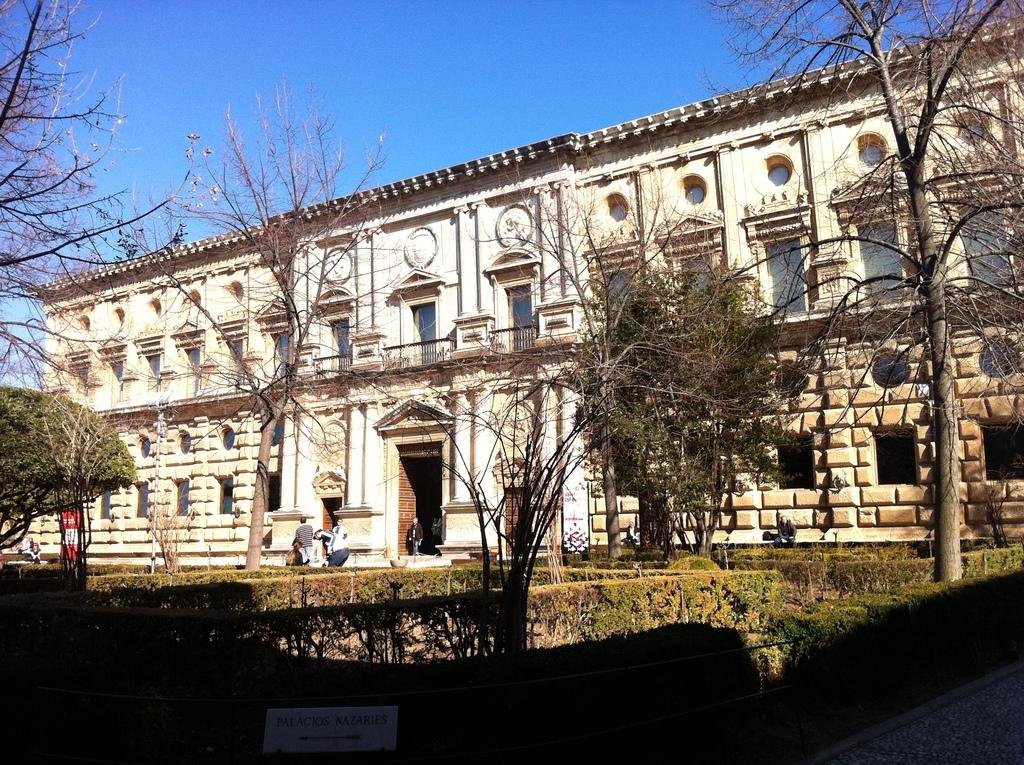What type of structure is in the image? A: There is a building in the image. What can be seen in front of the building? Trees are present in front of the building. What part of the natural environment is visible in the image? The land is visible in the image. What is visible above the building? The sky is visible above the building. How many muscles can be seen flexing in the image? There are no muscles visible in the image, as it features a building, trees, land, and sky. 